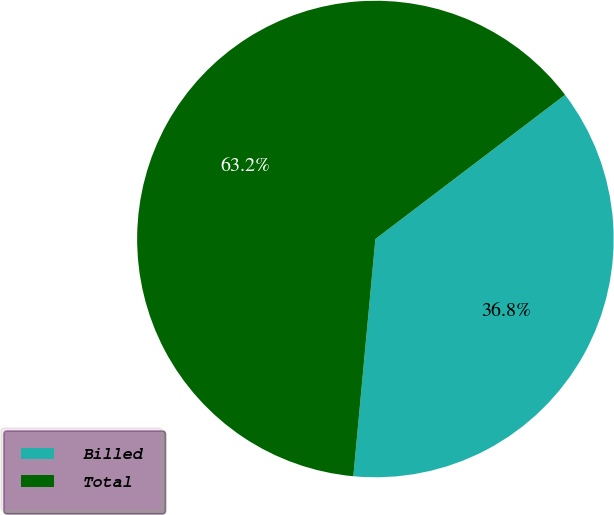<chart> <loc_0><loc_0><loc_500><loc_500><pie_chart><fcel>Billed<fcel>Total<nl><fcel>36.82%<fcel>63.18%<nl></chart> 